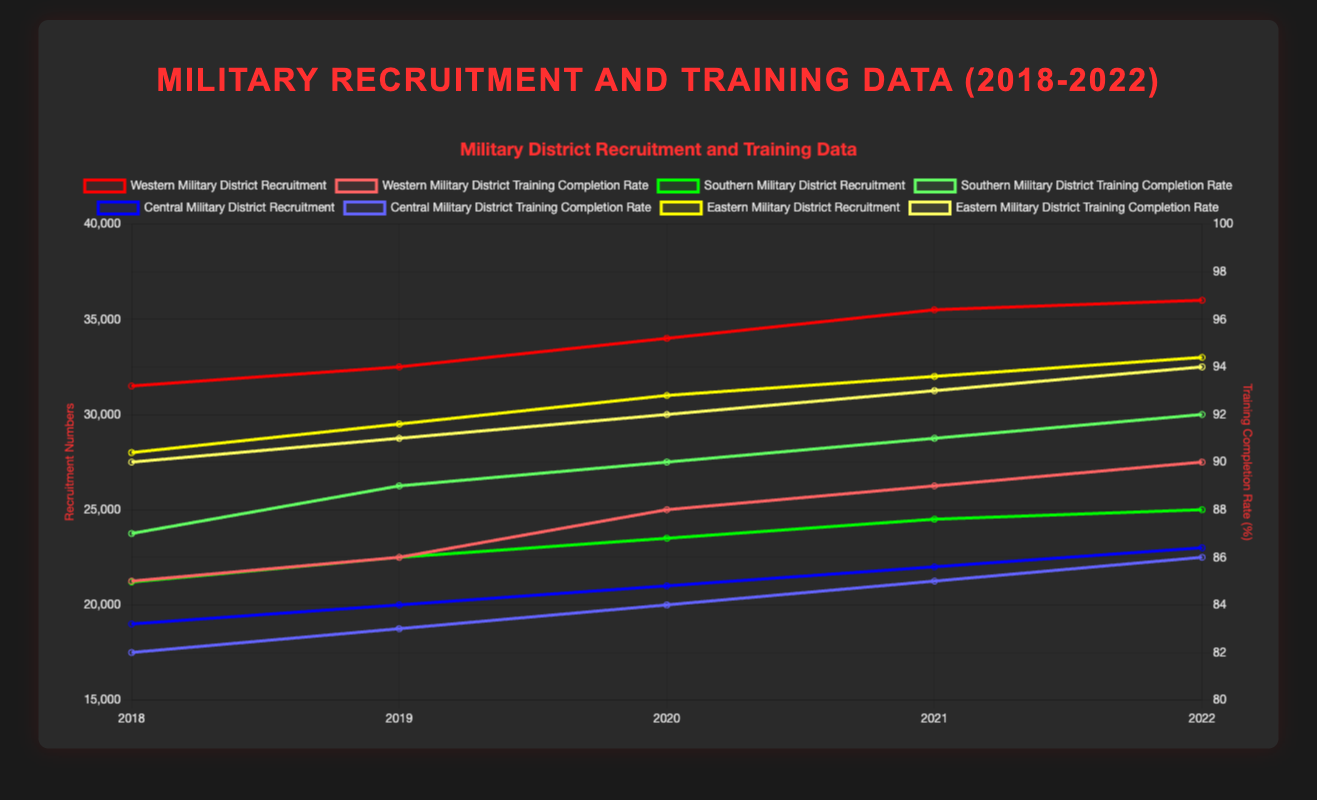Which Military District had the highest recruitment numbers in 2022? The Eastern Military District had the highest recruitment numbers in 2022, as depicted in the chart with a recruitment number of 33,000.
Answer: Eastern Military District How did the training completion rate for the Central Military District change from 2018 to 2022? The training completion rate for the Central Military District increased from 82% in 2018 to 86% in 2022.
Answer: Increased from 82% to 86% Which year saw the highest training completion rate in the Southern Military District? In 2022, the Southern Military District had the highest training completion rate at 92%.
Answer: 2022 What is the trend in recruitment numbers for the Western Military District from 2018 to 2022? The recruitment numbers for the Western Military District show a steady increase over the period from 31,500 in 2018 to 36,000 in 2022.
Answer: Increasing trend Compare the recruitment numbers for the Western and Central Military Districts in 2020. In 2020, the Western Military District had a recruitment number of 34,000 while the Central Military District had 21,000.
Answer: Western: 34,000, Central: 21,000 What is the average training completion rate for the Eastern Military District over the period 2018-2022? The training completion rates for the Eastern Military District are 90%, 91%, 92%, 93%, and 94% over the years 2018 to 2022. Summing these up gives 460%, and the average is 460/5 = 92%.
Answer: 92% Which year had the largest increase in recruitment numbers for the Southern Military District? The largest increase in recruitment numbers for the Southern Military District was from 2018 (21,200) to 2019 (22,500) which is an increase of 1,300.
Answer: 2019 What was the difference between the recruitment numbers of the Eastern and Western Military Districts in 2021? In 2021, the recruitment numbers for the Eastern Military District was 32,000 and for the Western Military District was 35,500. The difference is 35,500 - 32,000 = 3,500.
Answer: 3,500 Which Military District had the highest cumulative recruitment numbers from 2018 to 2022? To find the highest cumulative recruitment numbers, sum the recruitment for each district across the years:
Western: 31,500 + 32,500 + 34,000 + 35,500 + 36,000 = 169,500
Southern: 21,200 + 22,500 + 23,500 + 24,500 + 25,000 = 116,700
Central: 19,000 + 20,000 + 21,000 + 22,000 + 23,000 = 105,000
Eastern: 28,000 + 29,500 + 31,000 + 32,000 + 33,000 = 153,500
The Western Military District has the highest cumulative recruitment numbers.
Answer: Western Military District Which Military District exhibited the most consistent training completion rates over the years 2018-2022? The Western Military District exhibited training completion rates of 85%, 86%, 88%, 89%, and 90%, which shows a gradual and consistent increase compared to other districts.
Answer: Western Military District 